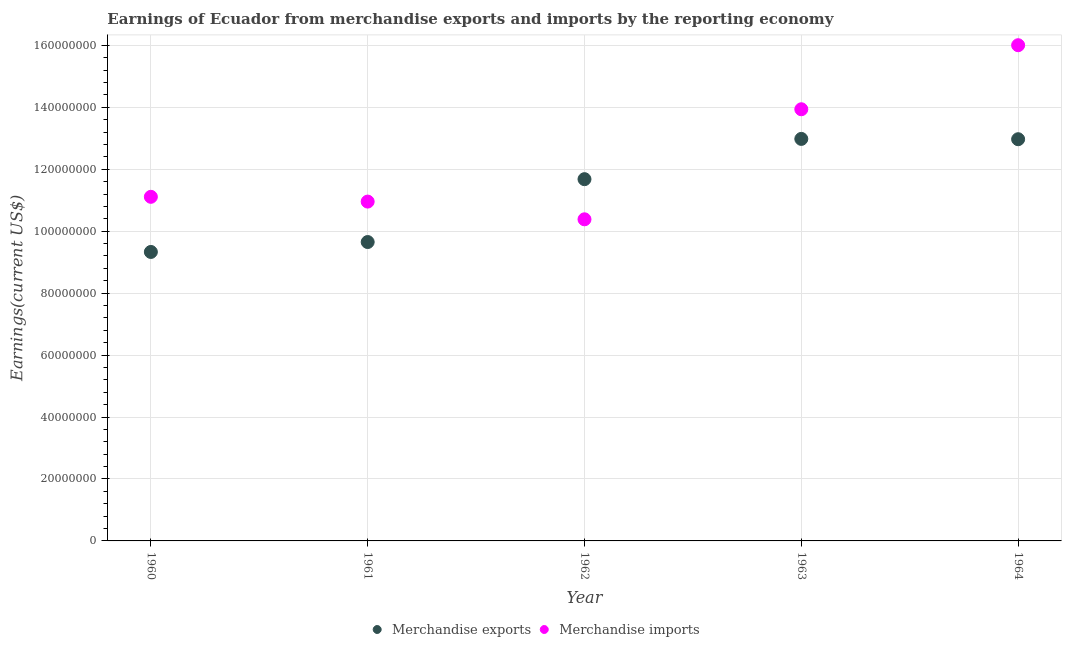Is the number of dotlines equal to the number of legend labels?
Make the answer very short. Yes. What is the earnings from merchandise exports in 1962?
Keep it short and to the point. 1.17e+08. Across all years, what is the maximum earnings from merchandise imports?
Keep it short and to the point. 1.60e+08. Across all years, what is the minimum earnings from merchandise imports?
Ensure brevity in your answer.  1.04e+08. In which year was the earnings from merchandise imports maximum?
Your response must be concise. 1964. What is the total earnings from merchandise imports in the graph?
Ensure brevity in your answer.  6.24e+08. What is the difference between the earnings from merchandise exports in 1963 and that in 1964?
Ensure brevity in your answer.  1.00e+05. What is the difference between the earnings from merchandise exports in 1962 and the earnings from merchandise imports in 1961?
Make the answer very short. 7.24e+06. What is the average earnings from merchandise exports per year?
Provide a succinct answer. 1.13e+08. In the year 1961, what is the difference between the earnings from merchandise exports and earnings from merchandise imports?
Keep it short and to the point. -1.31e+07. What is the ratio of the earnings from merchandise exports in 1962 to that in 1964?
Provide a short and direct response. 0.9. Is the difference between the earnings from merchandise imports in 1961 and 1962 greater than the difference between the earnings from merchandise exports in 1961 and 1962?
Provide a short and direct response. Yes. What is the difference between the highest and the second highest earnings from merchandise imports?
Make the answer very short. 2.07e+07. What is the difference between the highest and the lowest earnings from merchandise imports?
Give a very brief answer. 5.62e+07. In how many years, is the earnings from merchandise exports greater than the average earnings from merchandise exports taken over all years?
Offer a very short reply. 3. Is the sum of the earnings from merchandise imports in 1963 and 1964 greater than the maximum earnings from merchandise exports across all years?
Ensure brevity in your answer.  Yes. Does the earnings from merchandise imports monotonically increase over the years?
Give a very brief answer. No. Is the earnings from merchandise imports strictly greater than the earnings from merchandise exports over the years?
Ensure brevity in your answer.  No. How many years are there in the graph?
Offer a very short reply. 5. What is the difference between two consecutive major ticks on the Y-axis?
Give a very brief answer. 2.00e+07. Are the values on the major ticks of Y-axis written in scientific E-notation?
Offer a very short reply. No. Does the graph contain any zero values?
Provide a short and direct response. No. Where does the legend appear in the graph?
Your answer should be very brief. Bottom center. How many legend labels are there?
Offer a very short reply. 2. How are the legend labels stacked?
Ensure brevity in your answer.  Horizontal. What is the title of the graph?
Your response must be concise. Earnings of Ecuador from merchandise exports and imports by the reporting economy. What is the label or title of the Y-axis?
Make the answer very short. Earnings(current US$). What is the Earnings(current US$) of Merchandise exports in 1960?
Offer a terse response. 9.33e+07. What is the Earnings(current US$) of Merchandise imports in 1960?
Your response must be concise. 1.11e+08. What is the Earnings(current US$) of Merchandise exports in 1961?
Provide a succinct answer. 9.65e+07. What is the Earnings(current US$) in Merchandise imports in 1961?
Offer a very short reply. 1.10e+08. What is the Earnings(current US$) of Merchandise exports in 1962?
Provide a succinct answer. 1.17e+08. What is the Earnings(current US$) in Merchandise imports in 1962?
Offer a terse response. 1.04e+08. What is the Earnings(current US$) in Merchandise exports in 1963?
Ensure brevity in your answer.  1.30e+08. What is the Earnings(current US$) of Merchandise imports in 1963?
Offer a very short reply. 1.39e+08. What is the Earnings(current US$) in Merchandise exports in 1964?
Give a very brief answer. 1.30e+08. What is the Earnings(current US$) of Merchandise imports in 1964?
Your answer should be very brief. 1.60e+08. Across all years, what is the maximum Earnings(current US$) in Merchandise exports?
Provide a succinct answer. 1.30e+08. Across all years, what is the maximum Earnings(current US$) of Merchandise imports?
Offer a terse response. 1.60e+08. Across all years, what is the minimum Earnings(current US$) in Merchandise exports?
Provide a short and direct response. 9.33e+07. Across all years, what is the minimum Earnings(current US$) in Merchandise imports?
Offer a very short reply. 1.04e+08. What is the total Earnings(current US$) of Merchandise exports in the graph?
Offer a terse response. 5.66e+08. What is the total Earnings(current US$) in Merchandise imports in the graph?
Keep it short and to the point. 6.24e+08. What is the difference between the Earnings(current US$) of Merchandise exports in 1960 and that in 1961?
Provide a succinct answer. -3.20e+06. What is the difference between the Earnings(current US$) of Merchandise imports in 1960 and that in 1961?
Give a very brief answer. 1.54e+06. What is the difference between the Earnings(current US$) in Merchandise exports in 1960 and that in 1962?
Keep it short and to the point. -2.35e+07. What is the difference between the Earnings(current US$) of Merchandise imports in 1960 and that in 1962?
Provide a succinct answer. 7.26e+06. What is the difference between the Earnings(current US$) in Merchandise exports in 1960 and that in 1963?
Provide a short and direct response. -3.65e+07. What is the difference between the Earnings(current US$) in Merchandise imports in 1960 and that in 1963?
Give a very brief answer. -2.83e+07. What is the difference between the Earnings(current US$) in Merchandise exports in 1960 and that in 1964?
Offer a terse response. -3.64e+07. What is the difference between the Earnings(current US$) of Merchandise imports in 1960 and that in 1964?
Ensure brevity in your answer.  -4.90e+07. What is the difference between the Earnings(current US$) in Merchandise exports in 1961 and that in 1962?
Your answer should be compact. -2.03e+07. What is the difference between the Earnings(current US$) of Merchandise imports in 1961 and that in 1962?
Ensure brevity in your answer.  5.72e+06. What is the difference between the Earnings(current US$) of Merchandise exports in 1961 and that in 1963?
Your answer should be very brief. -3.33e+07. What is the difference between the Earnings(current US$) in Merchandise imports in 1961 and that in 1963?
Make the answer very short. -2.98e+07. What is the difference between the Earnings(current US$) in Merchandise exports in 1961 and that in 1964?
Give a very brief answer. -3.32e+07. What is the difference between the Earnings(current US$) of Merchandise imports in 1961 and that in 1964?
Provide a succinct answer. -5.05e+07. What is the difference between the Earnings(current US$) in Merchandise exports in 1962 and that in 1963?
Provide a short and direct response. -1.30e+07. What is the difference between the Earnings(current US$) of Merchandise imports in 1962 and that in 1963?
Give a very brief answer. -3.55e+07. What is the difference between the Earnings(current US$) of Merchandise exports in 1962 and that in 1964?
Your answer should be compact. -1.29e+07. What is the difference between the Earnings(current US$) of Merchandise imports in 1962 and that in 1964?
Your response must be concise. -5.62e+07. What is the difference between the Earnings(current US$) of Merchandise exports in 1963 and that in 1964?
Give a very brief answer. 1.00e+05. What is the difference between the Earnings(current US$) in Merchandise imports in 1963 and that in 1964?
Keep it short and to the point. -2.07e+07. What is the difference between the Earnings(current US$) in Merchandise exports in 1960 and the Earnings(current US$) in Merchandise imports in 1961?
Provide a short and direct response. -1.63e+07. What is the difference between the Earnings(current US$) of Merchandise exports in 1960 and the Earnings(current US$) of Merchandise imports in 1962?
Make the answer very short. -1.05e+07. What is the difference between the Earnings(current US$) in Merchandise exports in 1960 and the Earnings(current US$) in Merchandise imports in 1963?
Give a very brief answer. -4.61e+07. What is the difference between the Earnings(current US$) of Merchandise exports in 1960 and the Earnings(current US$) of Merchandise imports in 1964?
Offer a terse response. -6.68e+07. What is the difference between the Earnings(current US$) of Merchandise exports in 1961 and the Earnings(current US$) of Merchandise imports in 1962?
Ensure brevity in your answer.  -7.34e+06. What is the difference between the Earnings(current US$) of Merchandise exports in 1961 and the Earnings(current US$) of Merchandise imports in 1963?
Give a very brief answer. -4.29e+07. What is the difference between the Earnings(current US$) in Merchandise exports in 1961 and the Earnings(current US$) in Merchandise imports in 1964?
Your answer should be compact. -6.36e+07. What is the difference between the Earnings(current US$) of Merchandise exports in 1962 and the Earnings(current US$) of Merchandise imports in 1963?
Keep it short and to the point. -2.26e+07. What is the difference between the Earnings(current US$) in Merchandise exports in 1962 and the Earnings(current US$) in Merchandise imports in 1964?
Keep it short and to the point. -4.32e+07. What is the difference between the Earnings(current US$) in Merchandise exports in 1963 and the Earnings(current US$) in Merchandise imports in 1964?
Offer a terse response. -3.02e+07. What is the average Earnings(current US$) in Merchandise exports per year?
Your response must be concise. 1.13e+08. What is the average Earnings(current US$) of Merchandise imports per year?
Provide a short and direct response. 1.25e+08. In the year 1960, what is the difference between the Earnings(current US$) of Merchandise exports and Earnings(current US$) of Merchandise imports?
Offer a very short reply. -1.78e+07. In the year 1961, what is the difference between the Earnings(current US$) of Merchandise exports and Earnings(current US$) of Merchandise imports?
Make the answer very short. -1.31e+07. In the year 1962, what is the difference between the Earnings(current US$) in Merchandise exports and Earnings(current US$) in Merchandise imports?
Your answer should be compact. 1.30e+07. In the year 1963, what is the difference between the Earnings(current US$) of Merchandise exports and Earnings(current US$) of Merchandise imports?
Ensure brevity in your answer.  -9.57e+06. In the year 1964, what is the difference between the Earnings(current US$) in Merchandise exports and Earnings(current US$) in Merchandise imports?
Provide a short and direct response. -3.04e+07. What is the ratio of the Earnings(current US$) of Merchandise exports in 1960 to that in 1961?
Your answer should be very brief. 0.97. What is the ratio of the Earnings(current US$) in Merchandise imports in 1960 to that in 1961?
Make the answer very short. 1.01. What is the ratio of the Earnings(current US$) of Merchandise exports in 1960 to that in 1962?
Offer a very short reply. 0.8. What is the ratio of the Earnings(current US$) of Merchandise imports in 1960 to that in 1962?
Ensure brevity in your answer.  1.07. What is the ratio of the Earnings(current US$) of Merchandise exports in 1960 to that in 1963?
Offer a terse response. 0.72. What is the ratio of the Earnings(current US$) of Merchandise imports in 1960 to that in 1963?
Your answer should be very brief. 0.8. What is the ratio of the Earnings(current US$) of Merchandise exports in 1960 to that in 1964?
Offer a very short reply. 0.72. What is the ratio of the Earnings(current US$) of Merchandise imports in 1960 to that in 1964?
Offer a terse response. 0.69. What is the ratio of the Earnings(current US$) of Merchandise exports in 1961 to that in 1962?
Ensure brevity in your answer.  0.83. What is the ratio of the Earnings(current US$) in Merchandise imports in 1961 to that in 1962?
Ensure brevity in your answer.  1.06. What is the ratio of the Earnings(current US$) in Merchandise exports in 1961 to that in 1963?
Offer a terse response. 0.74. What is the ratio of the Earnings(current US$) of Merchandise imports in 1961 to that in 1963?
Offer a very short reply. 0.79. What is the ratio of the Earnings(current US$) in Merchandise exports in 1961 to that in 1964?
Provide a succinct answer. 0.74. What is the ratio of the Earnings(current US$) in Merchandise imports in 1961 to that in 1964?
Keep it short and to the point. 0.68. What is the ratio of the Earnings(current US$) of Merchandise exports in 1962 to that in 1963?
Provide a short and direct response. 0.9. What is the ratio of the Earnings(current US$) in Merchandise imports in 1962 to that in 1963?
Ensure brevity in your answer.  0.75. What is the ratio of the Earnings(current US$) of Merchandise exports in 1962 to that in 1964?
Provide a succinct answer. 0.9. What is the ratio of the Earnings(current US$) of Merchandise imports in 1962 to that in 1964?
Your response must be concise. 0.65. What is the ratio of the Earnings(current US$) in Merchandise exports in 1963 to that in 1964?
Your answer should be compact. 1. What is the ratio of the Earnings(current US$) of Merchandise imports in 1963 to that in 1964?
Keep it short and to the point. 0.87. What is the difference between the highest and the second highest Earnings(current US$) in Merchandise exports?
Your answer should be compact. 1.00e+05. What is the difference between the highest and the second highest Earnings(current US$) of Merchandise imports?
Offer a terse response. 2.07e+07. What is the difference between the highest and the lowest Earnings(current US$) of Merchandise exports?
Offer a terse response. 3.65e+07. What is the difference between the highest and the lowest Earnings(current US$) in Merchandise imports?
Make the answer very short. 5.62e+07. 